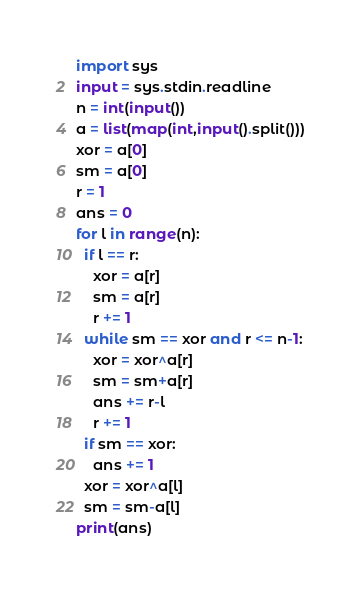Convert code to text. <code><loc_0><loc_0><loc_500><loc_500><_Python_>import sys
input = sys.stdin.readline
n = int(input())
a = list(map(int,input().split()))
xor = a[0]
sm = a[0]
r = 1
ans = 0
for l in range(n):
  if l == r:
    xor = a[r]
    sm = a[r]
    r += 1
  while sm == xor and r <= n-1:
    xor = xor^a[r]
    sm = sm+a[r]
    ans += r-l
    r += 1
  if sm == xor:
    ans += 1
  xor = xor^a[l]
  sm = sm-a[l]
print(ans)</code> 